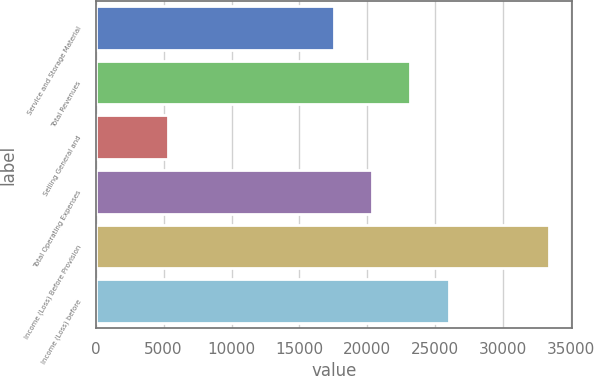Convert chart to OTSL. <chart><loc_0><loc_0><loc_500><loc_500><bar_chart><fcel>Service and Storage Material<fcel>Total Revenues<fcel>Selling General and<fcel>Total Operating Expenses<fcel>Income (Loss) Before Provision<fcel>Income (Loss) before<nl><fcel>17570<fcel>23176.6<fcel>5350<fcel>20373.3<fcel>33383<fcel>25979.9<nl></chart> 